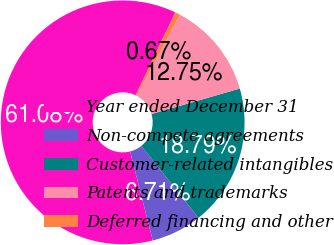Convert chart to OTSL. <chart><loc_0><loc_0><loc_500><loc_500><pie_chart><fcel>Year ended December 31<fcel>Non-compete agreements<fcel>Customer-related intangibles<fcel>Patents and trademarks<fcel>Deferred financing and other<nl><fcel>61.08%<fcel>6.71%<fcel>18.79%<fcel>12.75%<fcel>0.67%<nl></chart> 